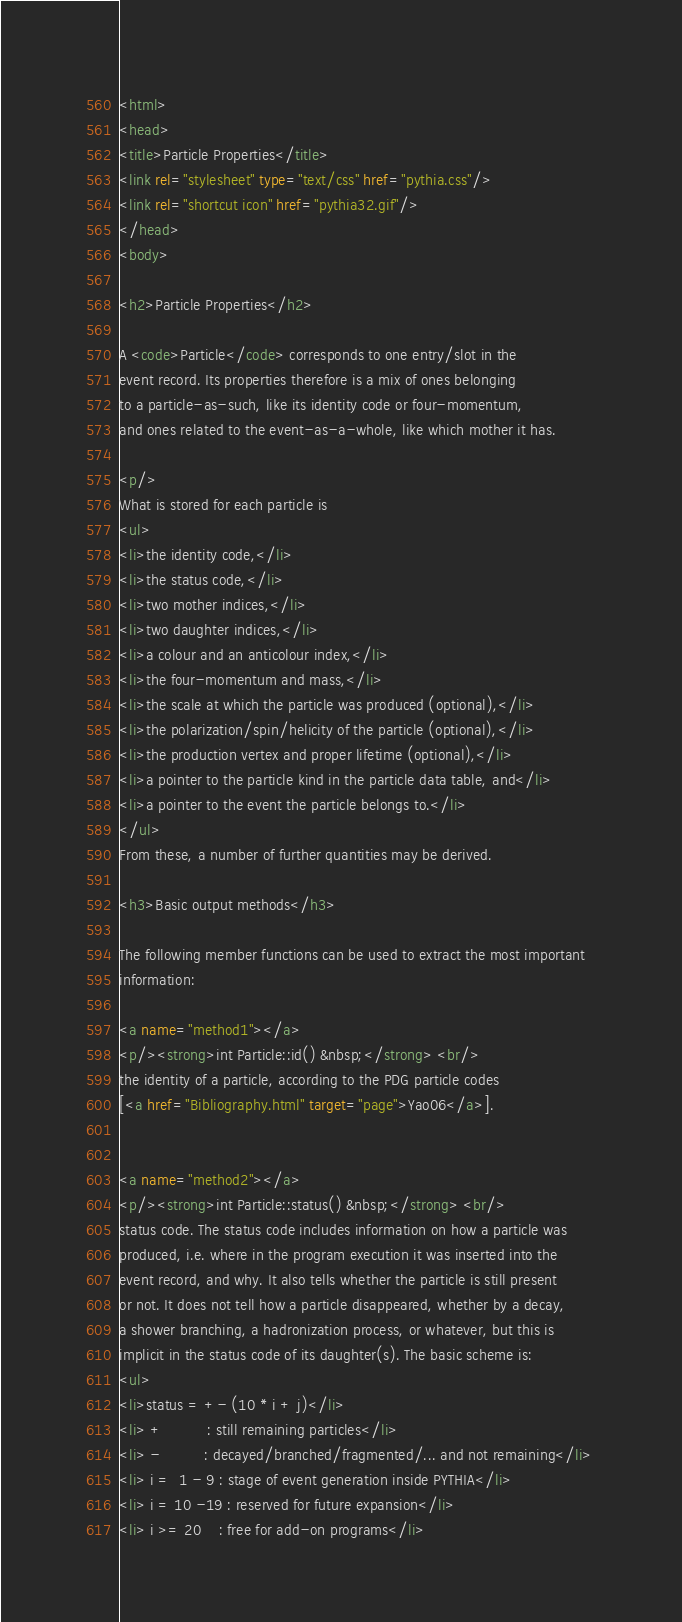Convert code to text. <code><loc_0><loc_0><loc_500><loc_500><_HTML_><html>
<head>
<title>Particle Properties</title>
<link rel="stylesheet" type="text/css" href="pythia.css"/>
<link rel="shortcut icon" href="pythia32.gif"/>
</head>
<body>
 
<h2>Particle Properties</h2> 
 
A <code>Particle</code> corresponds to one entry/slot in the 
event record. Its properties therefore is a mix of ones belonging 
to a particle-as-such, like its identity code or four-momentum, 
and ones related to the event-as-a-whole, like which mother it has. 
 
<p/> 
What is stored for each particle is 
<ul> 
<li>the identity code,</li> 
<li>the status code,</li> 
<li>two mother indices,</li> 
<li>two daughter indices,</li> 
<li>a colour and an anticolour index,</li> 
<li>the four-momentum and mass,</li> 
<li>the scale at which the particle was produced (optional),</li> 
<li>the polarization/spin/helicity of the particle (optional),</li> 
<li>the production vertex and proper lifetime (optional),</li> 
<li>a pointer to the particle kind in the particle data table, and</li> 
<li>a pointer to the event the particle belongs to.</li> 
</ul> 
From these, a number of further quantities may be derived. 
 
<h3>Basic output methods</h3> 
 
The following member functions can be used to extract the most important 
information: 
 
<a name="method1"></a>
<p/><strong>int Particle::id() &nbsp;</strong> <br/>
the identity of a particle, according to the PDG particle codes 
[<a href="Bibliography.html" target="page">Yao06</a>]. 
   
 
<a name="method2"></a>
<p/><strong>int Particle::status() &nbsp;</strong> <br/>
status code. The status code includes information on how a particle was 
produced, i.e. where in the program execution it was inserted into the 
event record, and why. It also tells whether the particle is still present 
or not. It does not tell how a particle disappeared, whether by a decay, 
a shower branching, a hadronization process, or whatever, but this is 
implicit in the status code of its daughter(s). The basic scheme is: 
<ul> 
<li>status = +- (10 * i + j)</li> 
<li> +          : still remaining particles</li> 
<li> -          : decayed/branched/fragmented/... and not remaining</li> 
<li> i =  1 - 9 : stage of event generation inside PYTHIA</li> 
<li> i = 10 -19 : reserved for future expansion</li> 
<li> i >= 20    : free for add-on programs</li> </code> 